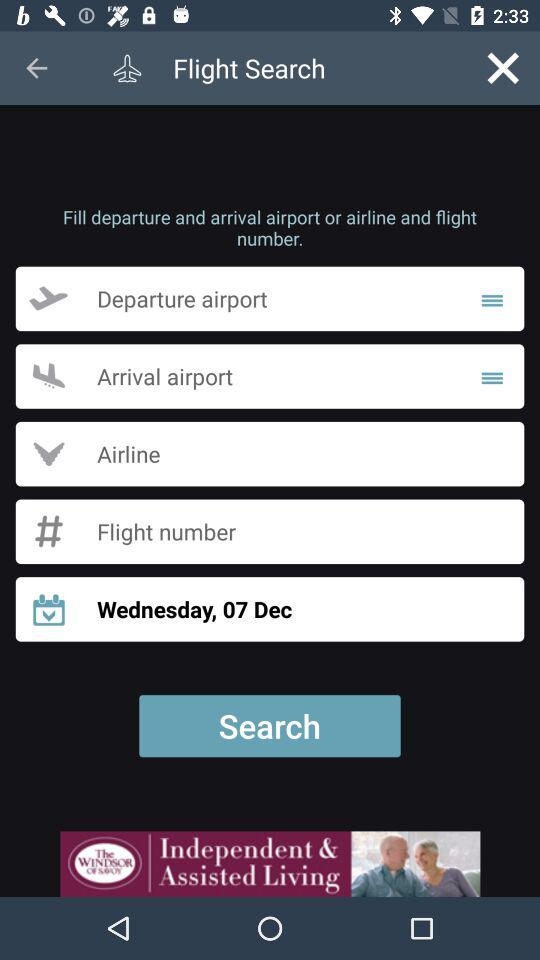What is the day on 07 December? The day is Wednesday. 